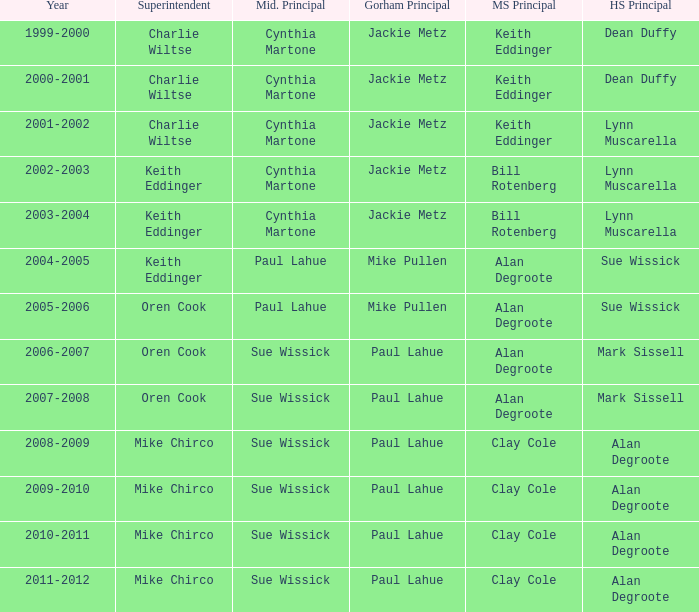Who were the middle school principal(s) in 2010-2011? Clay Cole. 